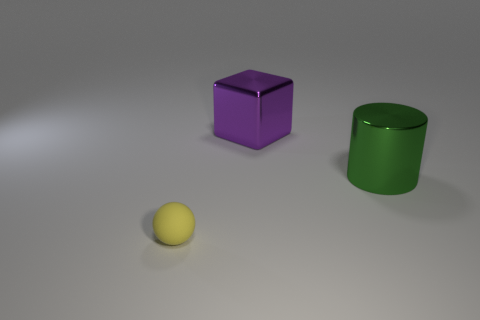How many things are tiny spheres or things that are behind the small yellow ball?
Make the answer very short. 3. Is the number of tiny balls that are to the right of the tiny yellow ball less than the number of tiny cylinders?
Provide a short and direct response. No. What size is the yellow object left of the large metallic thing that is in front of the purple block that is behind the green shiny object?
Ensure brevity in your answer.  Small. There is a thing that is both left of the large cylinder and in front of the large shiny cube; what color is it?
Keep it short and to the point. Yellow. What number of small red cylinders are there?
Keep it short and to the point. 0. Are there any other things that are the same size as the matte object?
Your answer should be very brief. No. Do the big purple object and the cylinder have the same material?
Provide a short and direct response. Yes. There is a object right of the purple object; is its size the same as the thing that is on the left side of the big metal cube?
Offer a very short reply. No. Is the number of green things less than the number of cyan matte blocks?
Provide a succinct answer. No. How many matte things are small balls or big purple cubes?
Offer a terse response. 1. 